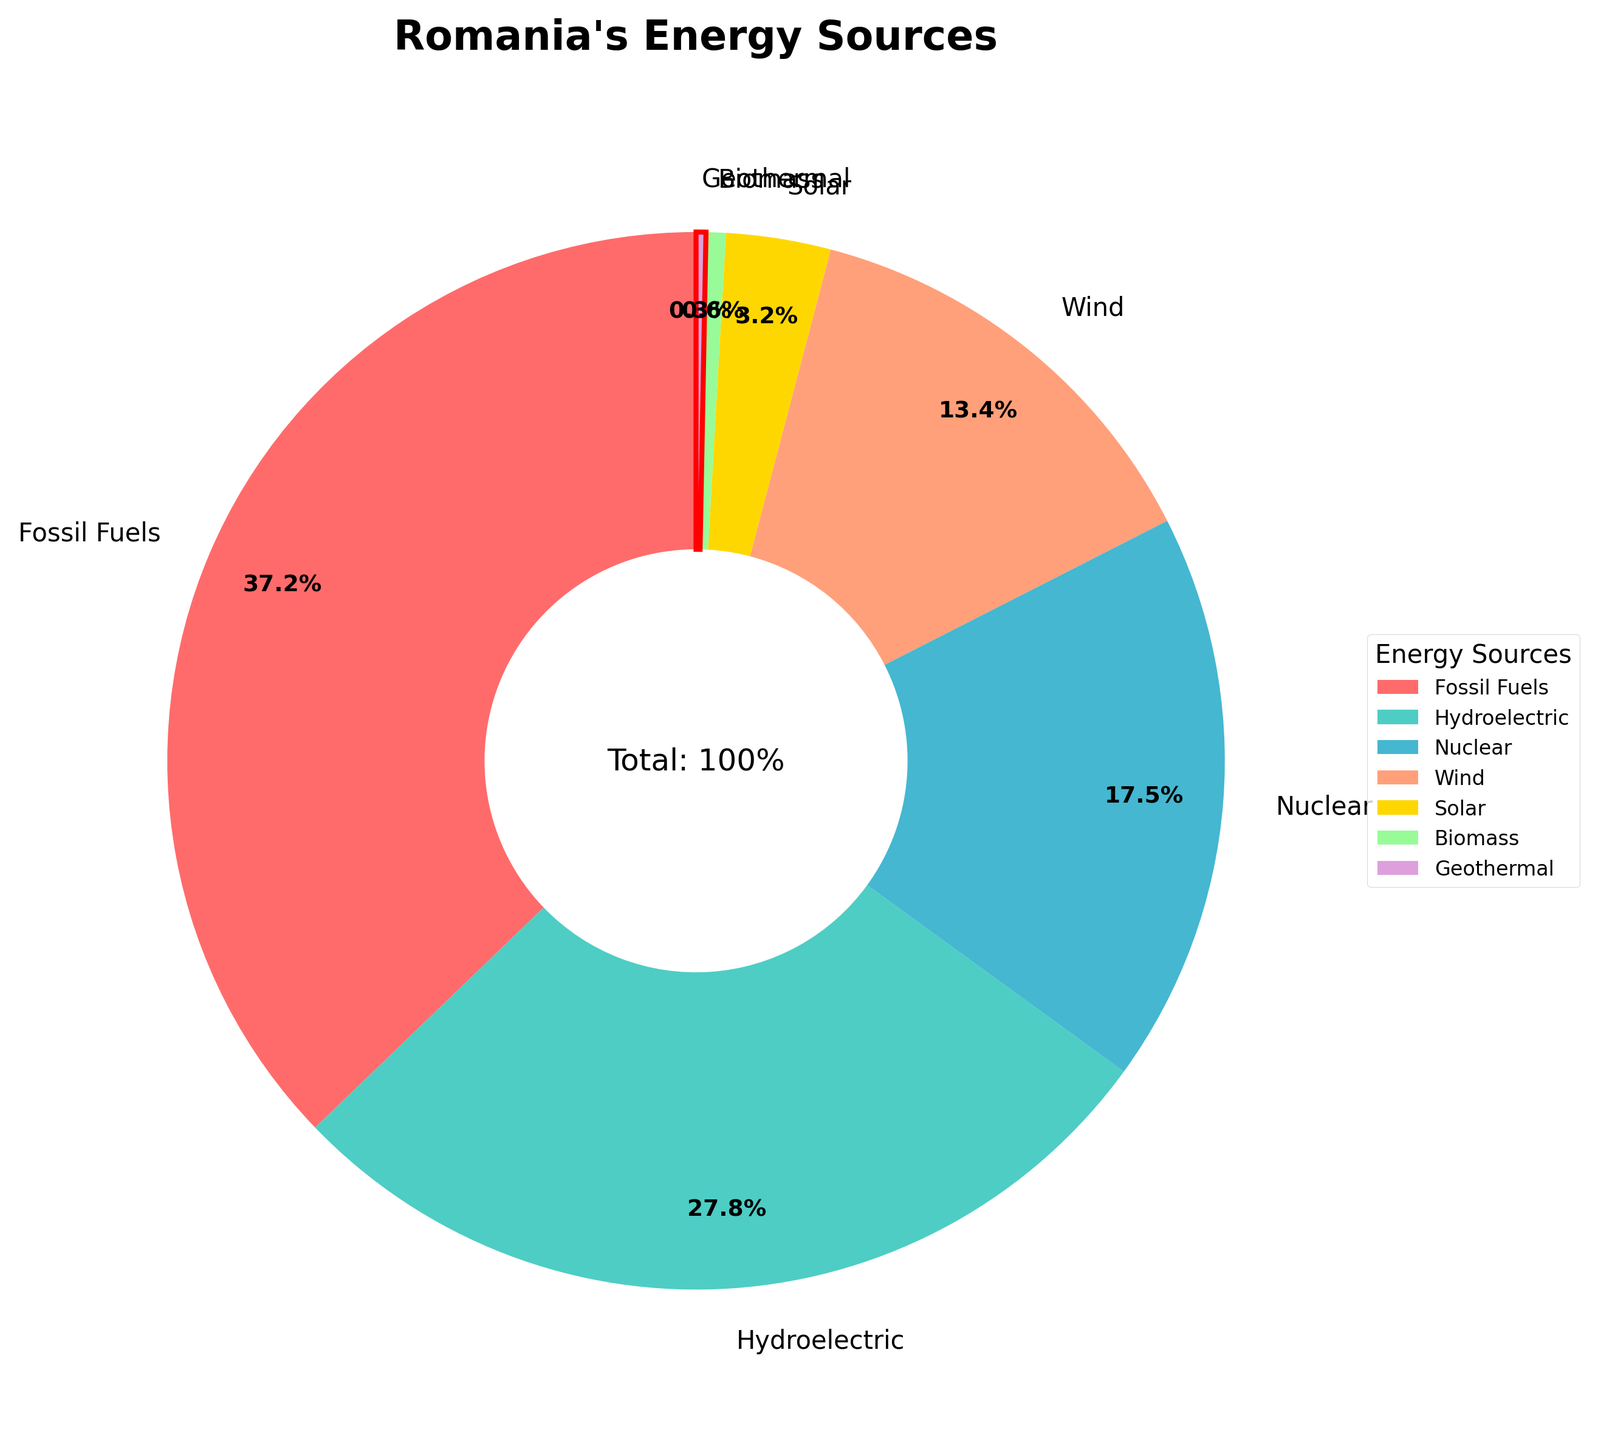What is the percentage of geothermal energy in Romania's energy sources? Geothermal energy is represented by a segment in the pie chart labeled 'Geothermal' with the percentage shown next to it.
Answer: 0.3% Which energy source has the highest percentage in Romania? The largest segment of the pie chart represents the highest percentage, which corresponds to 'Fossil Fuels' in the chart.
Answer: Fossil Fuels How does the percentage of wind energy compare to that of solar energy? Comparing the segments labeled 'Wind' and 'Solar' in the pie chart, the 'Wind' segment is larger, indicating a higher percentage. Wind energy is 13.4%, and solar energy is 3.2%.
Answer: Wind energy is higher What is the combined percentage of fossil fuels and nuclear energy in Romania? From the pie chart, the fossil fuels segment is 37.2% and the nuclear segment is 17.5%. Adding these two percentages gives 37.2% + 17.5%.
Answer: 54.7% Which color represents geothermal energy in the pie chart? Geothermal energy is highlighted with a red edge in the pie chart. Visually identifying this highlight allows us to recognize the color representing geothermal energy.
Answer: Purple How does the use of hydroelectric energy compare to nuclear energy in Romania? Hydroelectric energy's segment is 27.8%, and nuclear energy's segment is 17.5%. By comparing these two percentages, we see that hydroelectric energy is higher.
Answer: Hydroelectric energy is higher What is the total percentage of renewable energies (hydroelectric, wind, solar, and biomass) in Romania? The renewable energies listed are hydroelectric (27.8%), wind (13.4%), solar (3.2%), and biomass (0.6%). Adding these values gives 27.8% + 13.4% + 3.2% + 0.6%.
Answer: 45% How does the visual size of the geothermal energy segment compare to the biomass segment in the pie chart? In the pie chart, the geothermal segment is smaller compared to the biomass segment, as both the percentage (0.3% for geothermal) and the visual area are lesser in comparison to biomass (0.6%).
Answer: Geothermal is smaller 